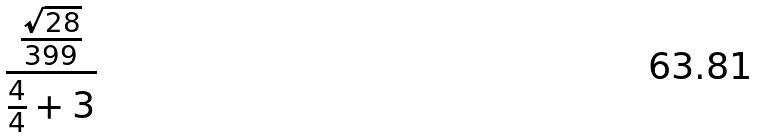Convert formula to latex. <formula><loc_0><loc_0><loc_500><loc_500>\frac { \frac { \sqrt { 2 8 } } { 3 9 9 } } { \frac { 4 } { 4 } + 3 }</formula> 